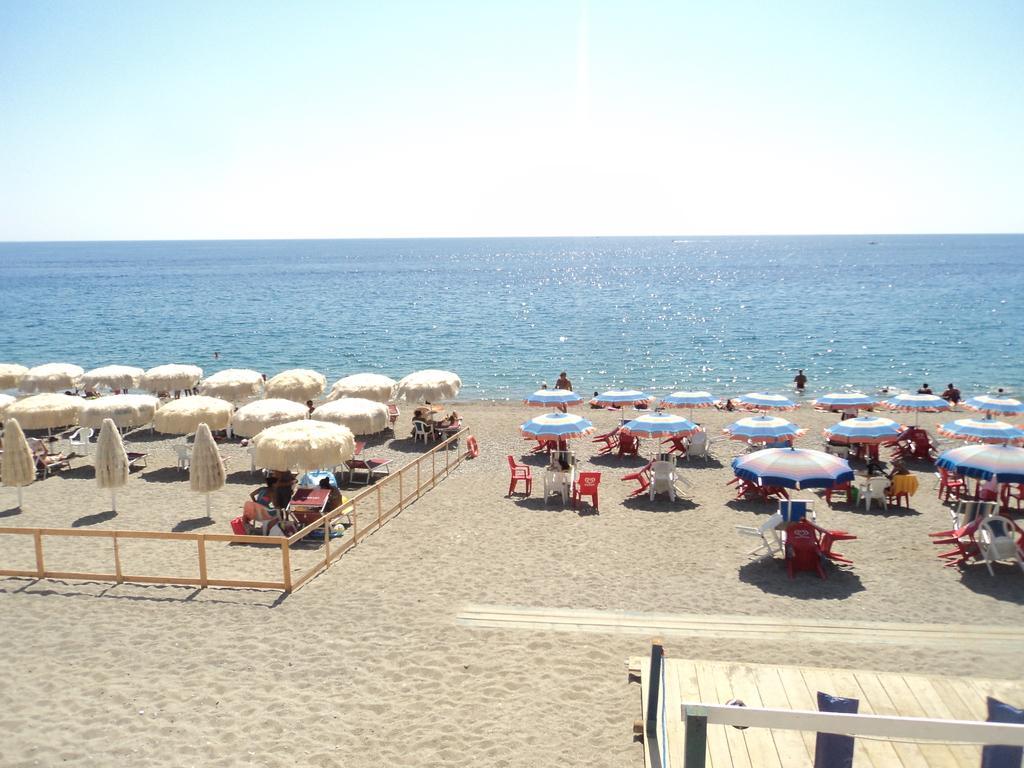Can you describe this image briefly? In this image we can see an ocean and beach area. On beach we can see table, chair and umbrellas. And people are swimming and sitting. The sky is clean. 